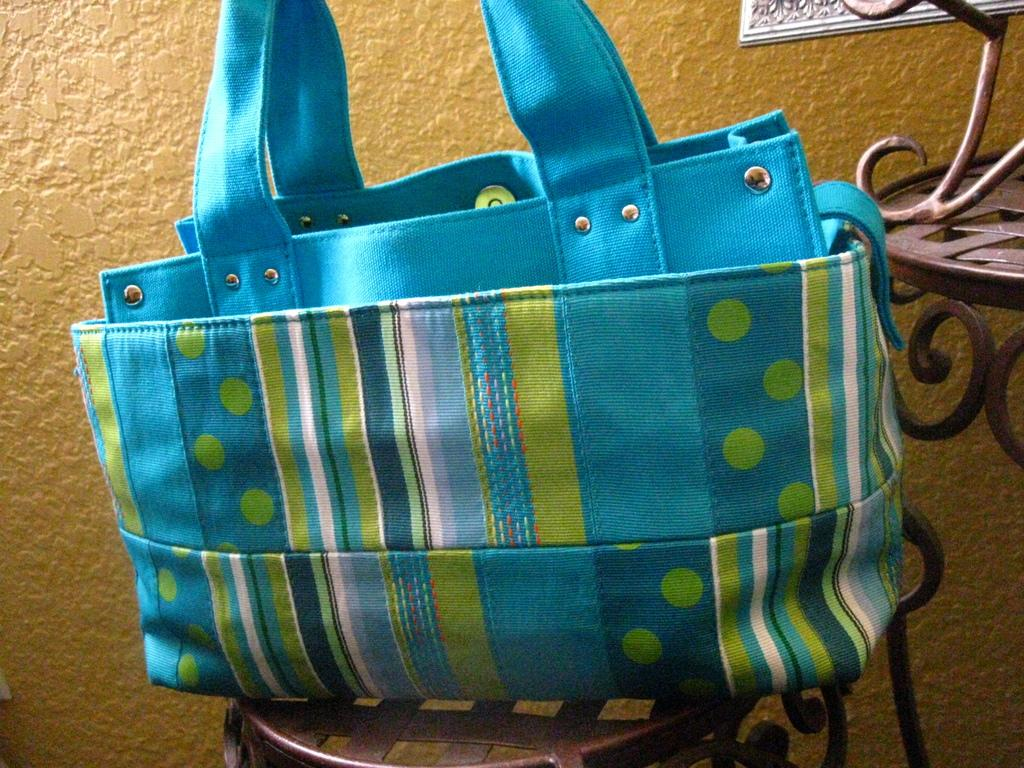What color is the bag that is visible in the image? The bag is blue in the image. Where is the bag located? The bag is on a chair in the image. What can be seen in the background of the image? There is a wall and a frame in the background of the image. Can you tell me how many times the giraffe sneezes in the image? There is no giraffe present in the image, so it is not possible to determine how many times it sneezes. What type of grip does the frame have in the image? The image does not provide enough detail to determine the type of grip the frame has. 